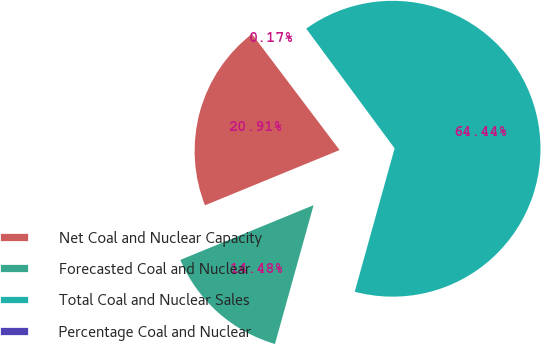<chart> <loc_0><loc_0><loc_500><loc_500><pie_chart><fcel>Net Coal and Nuclear Capacity<fcel>Forecasted Coal and Nuclear<fcel>Total Coal and Nuclear Sales<fcel>Percentage Coal and Nuclear<nl><fcel>20.91%<fcel>14.48%<fcel>64.44%<fcel>0.17%<nl></chart> 